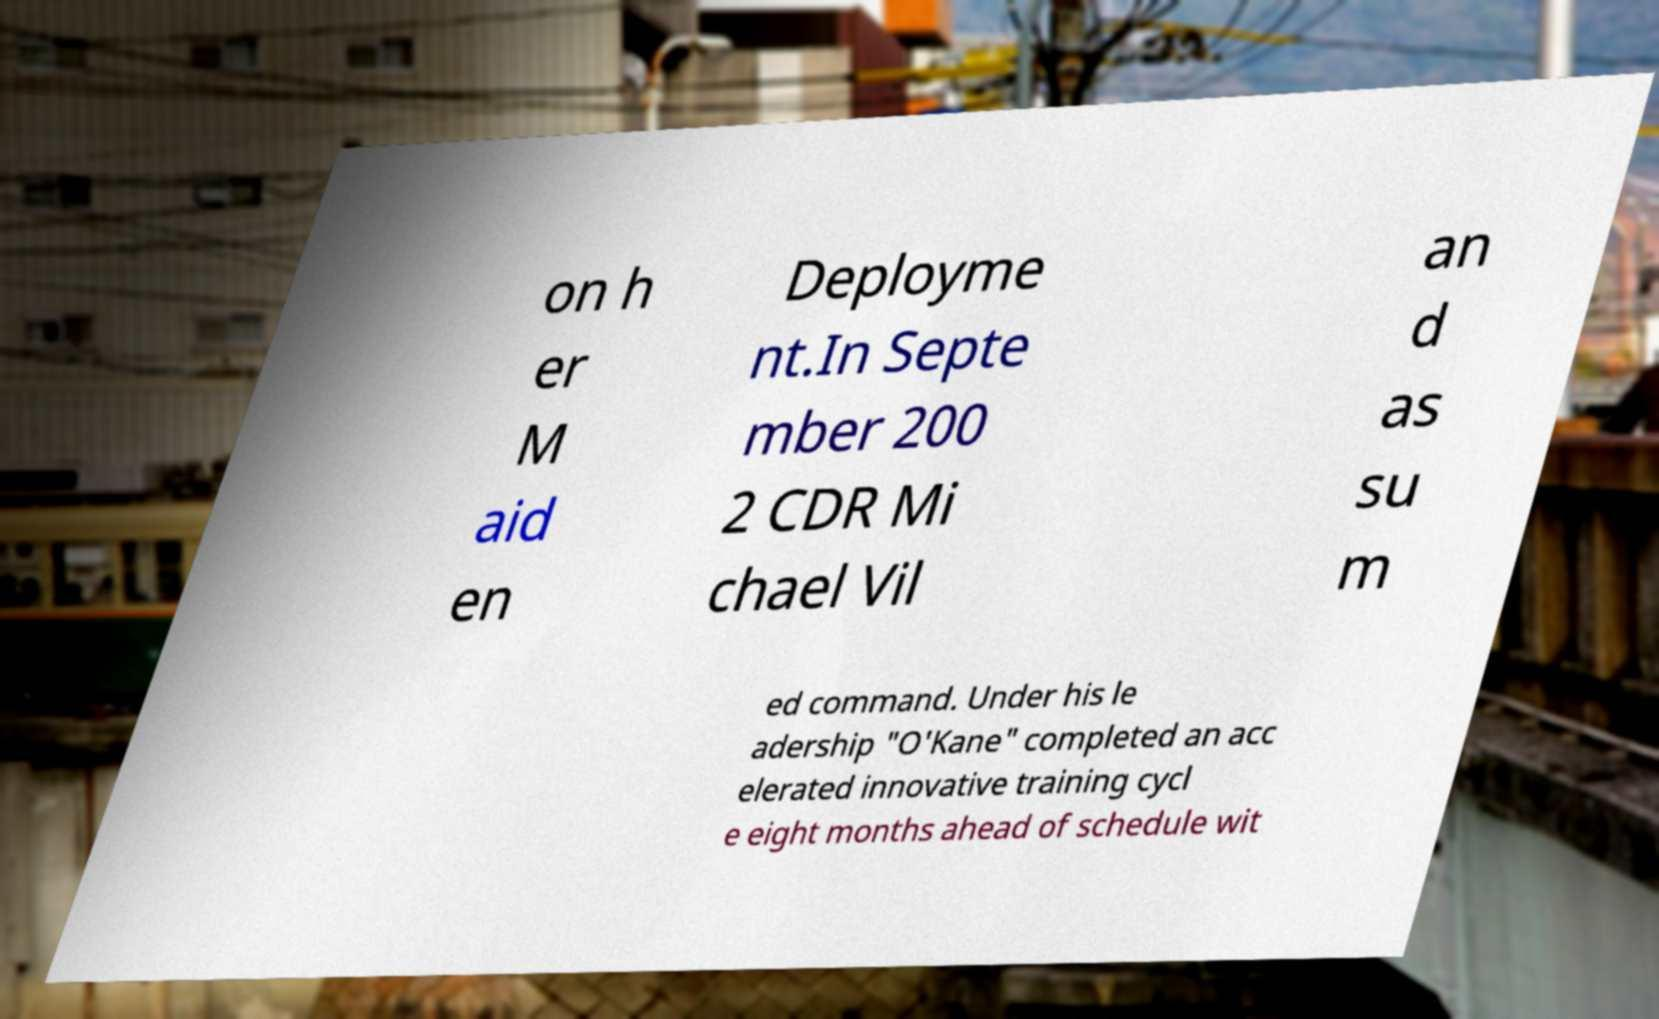Can you accurately transcribe the text from the provided image for me? on h er M aid en Deployme nt.In Septe mber 200 2 CDR Mi chael Vil an d as su m ed command. Under his le adership "O'Kane" completed an acc elerated innovative training cycl e eight months ahead of schedule wit 